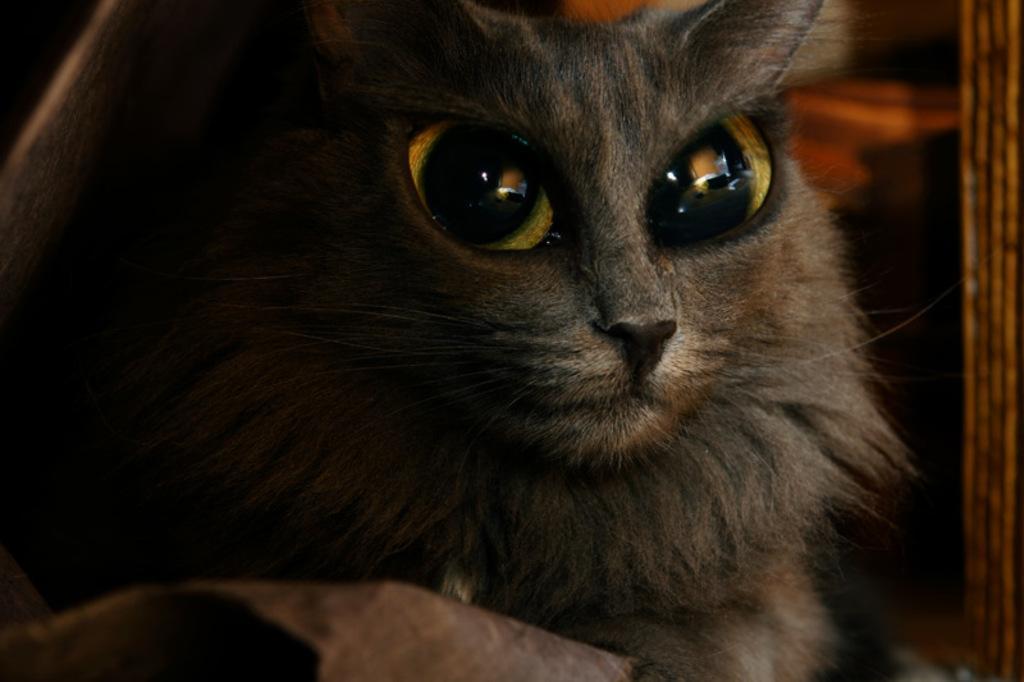Can you describe this image briefly? In this image there is a cat. 